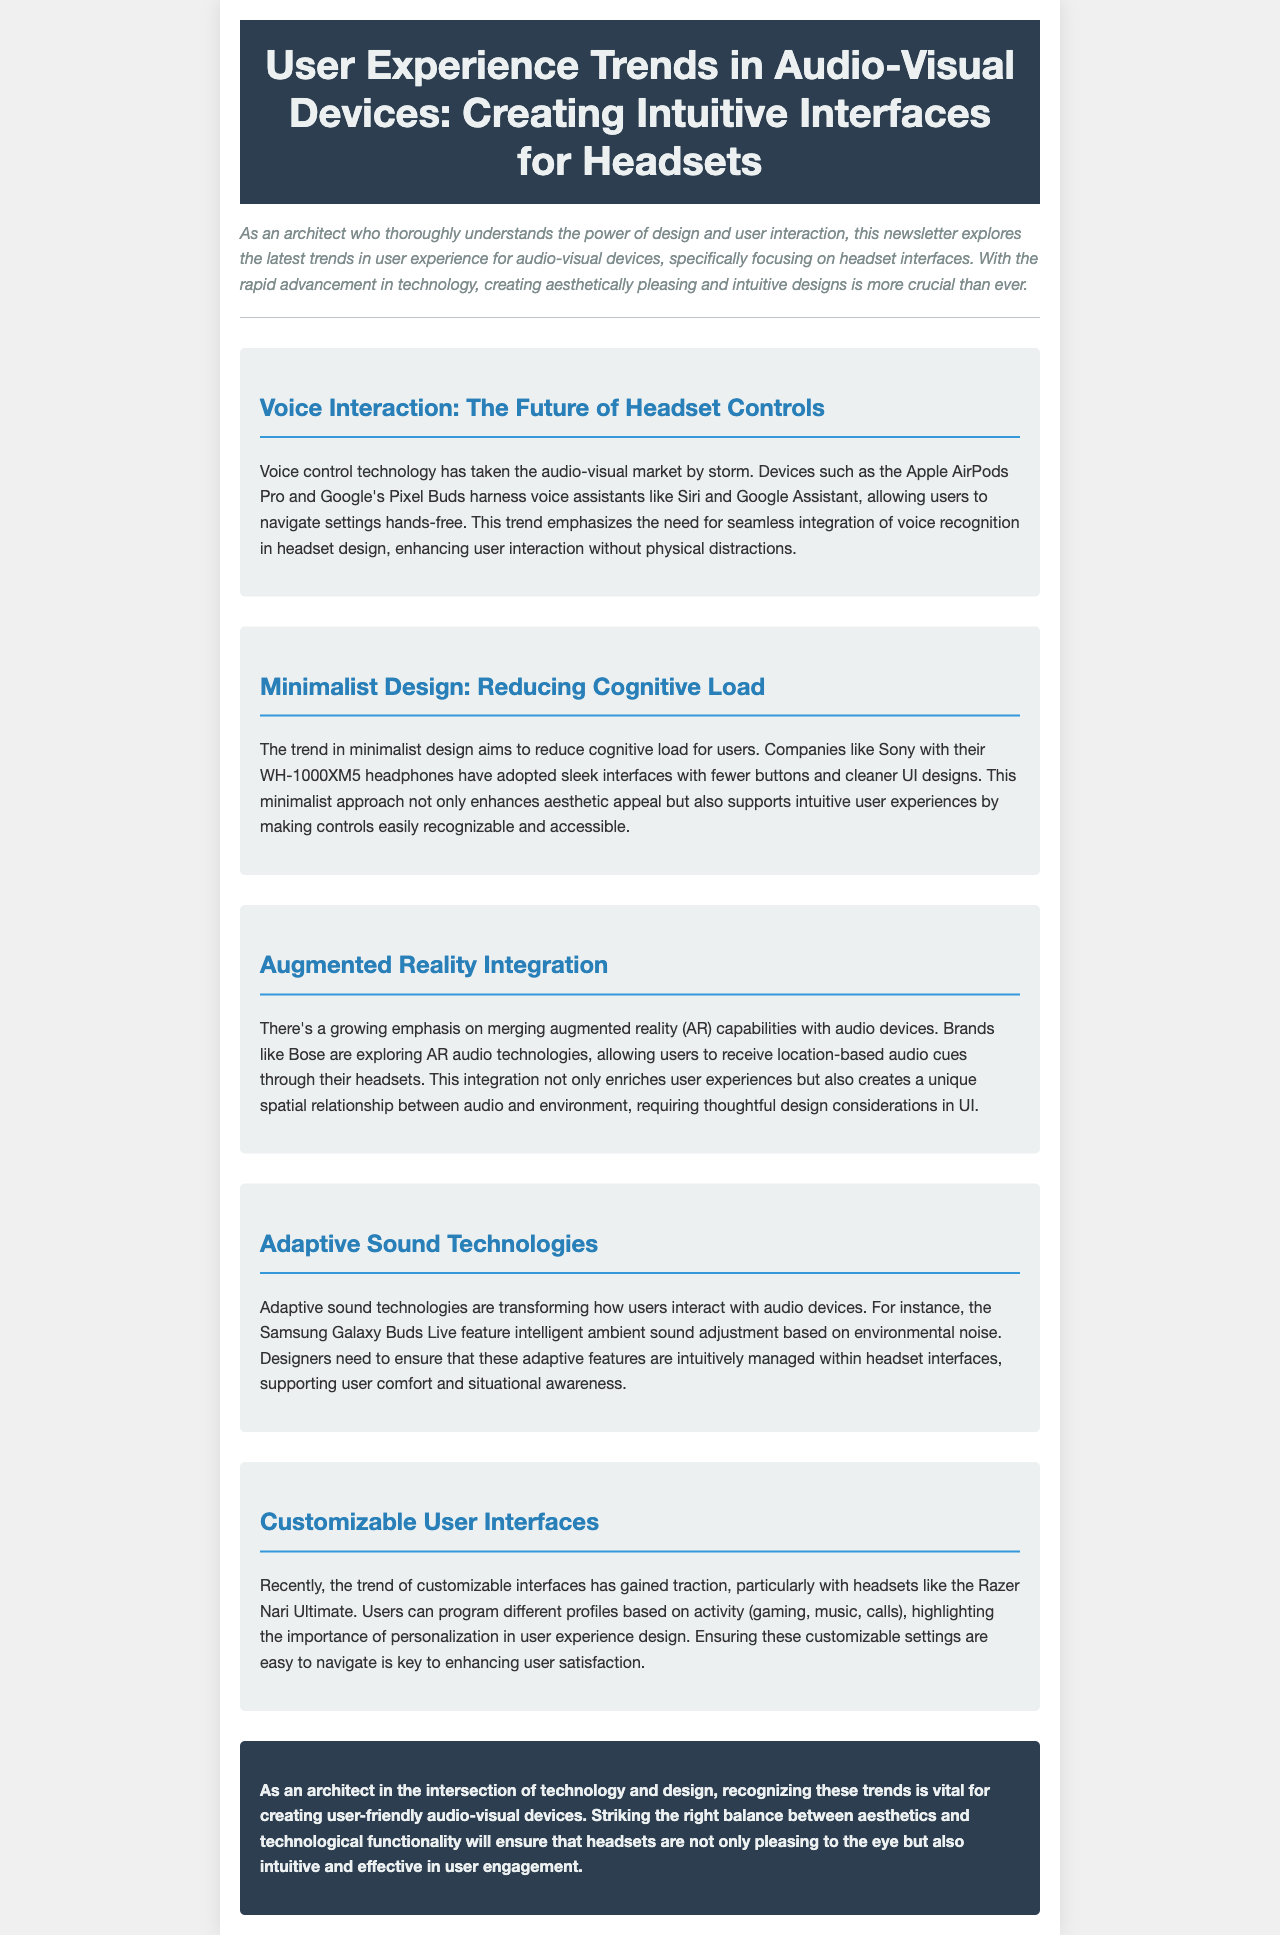What is the title of the newsletter? The title of the newsletter is featured prominently in the header section of the document, which is about user experience trends in audio-visual devices.
Answer: User Experience Trends in Audio-Visual Devices: Creating Intuitive Interfaces for Headsets Which company is mentioned as utilizing voice assistants in their headsets? The company mentioned that utilizes voice assistants like Siri and Google Assistant in their devices is discussed in relation to voice control technology.
Answer: Apple What design approach aims to reduce cognitive load for users? The document discusses a trend in headset design that focuses on simplifying user interaction and making controls easily accessible.
Answer: Minimalist Design What type of integration is highlighted with audio devices in the newsletter? The newsletter covers a trend involving the incorporation of additional technology into audio devices, specifically focusing on enhancing user experiences.
Answer: Augmented Reality Integration Which headset model features adaptive sound technologies according to the newsletter? The document mentions a specific model known for its ambient sound adjustment capabilities, which exemplifies adaptive sound technology.
Answer: Samsung Galaxy Buds Live What is the primary goal of customizable user interfaces in headsets? Customizable user interfaces in headsets aim to improve a particular aspect of user experience, allowing users to tailor settings according to their preferences.
Answer: Personalization How does the newsletter describe the relationship between aesthetics and functionality? The conclusion highlights the necessity of balancing visual appeal with practical use in headset design, as stated by the author.
Answer: Striking the right balance 